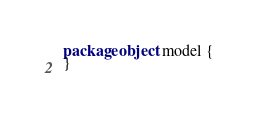Convert code to text. <code><loc_0><loc_0><loc_500><loc_500><_Scala_>package object model {
}

</code> 